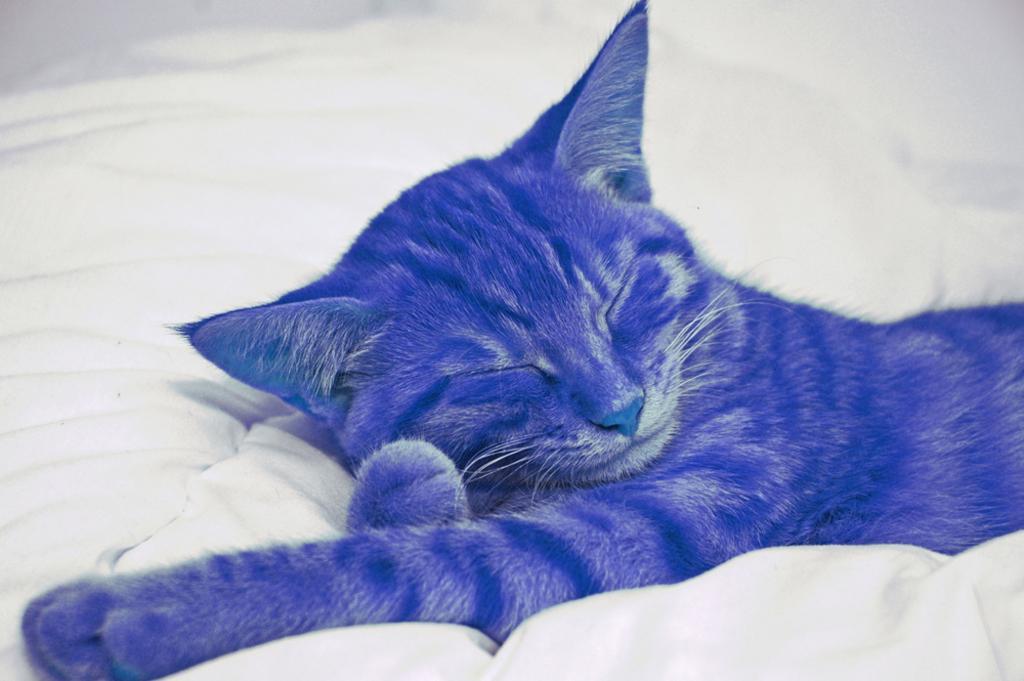Could you give a brief overview of what you see in this image? In this image there is a blue color cat sleeping on the bed. 